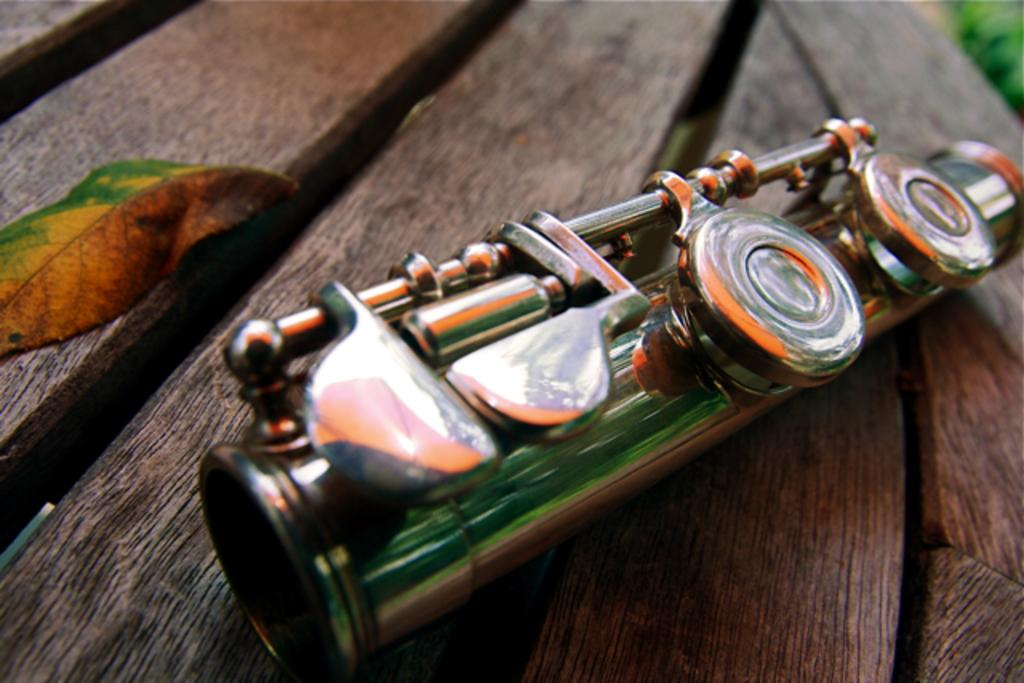What object is located in the middle of the image? There is a musical instrument in the middle of the image. What is the position of the leaf in the image? The leaf is on the left side of the image. What is the background of the image? The background of the image is not mentioned in the facts provided. What is the relationship between the musical instrument and the leaf in the image? Both the musical instrument and the leaf are placed on a table in the image. What type of pin is holding the jeans in the image? There is no pin or jeans present in the image. Can you describe the bee that is buzzing around the musical instrument in the image? There is no bee present in the image. 